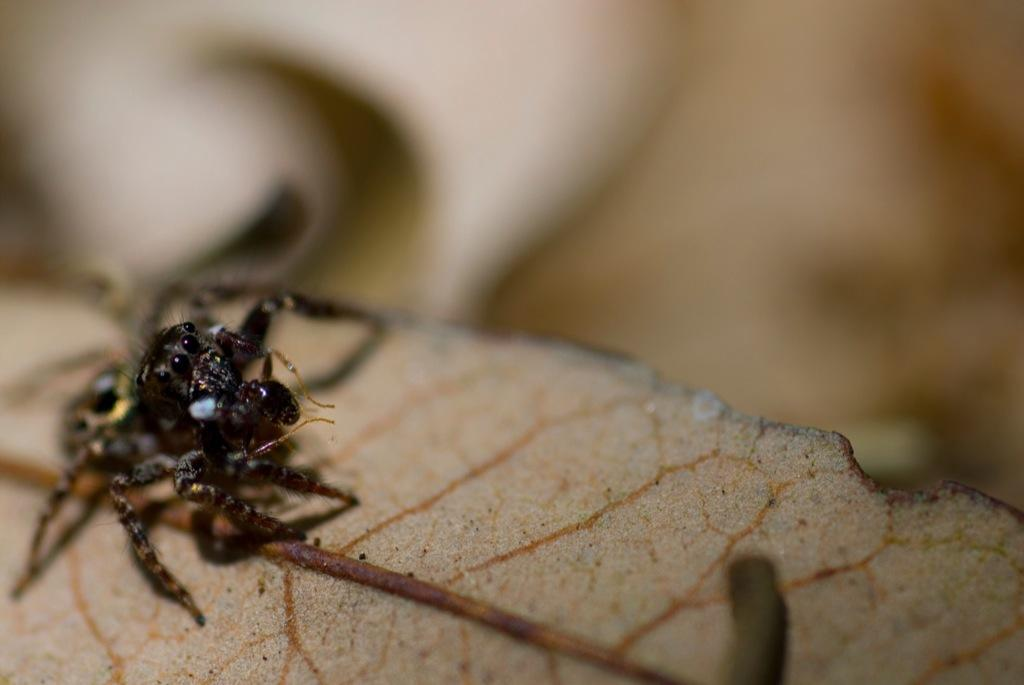What type of creature can be seen in the image? There is an insect in the image. Where is the insect located? The insect is on a leaf. Can you describe the background of the image? The background of the image is blurry. What type of pig can be seen eating cherries in the image? There is no pig or cherries present in the image; it features an insect on a leaf. What type of cast is visible in the image? There is no cast present in the image. 